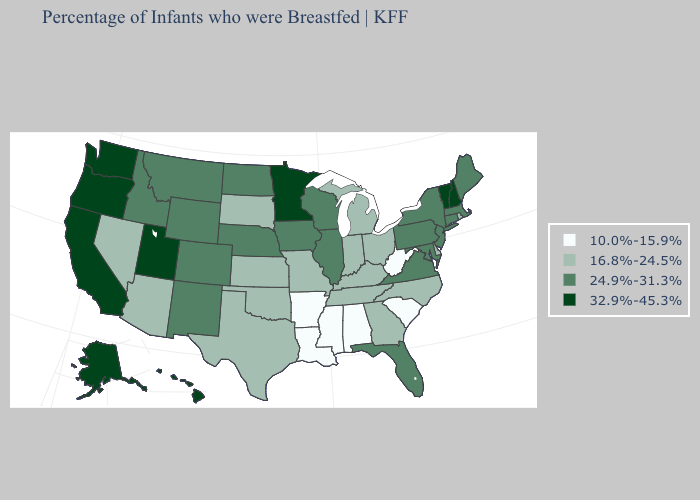Does the first symbol in the legend represent the smallest category?
Give a very brief answer. Yes. Name the states that have a value in the range 32.9%-45.3%?
Quick response, please. Alaska, California, Hawaii, Minnesota, New Hampshire, Oregon, Utah, Vermont, Washington. What is the lowest value in the West?
Answer briefly. 16.8%-24.5%. Does Virginia have a lower value than Rhode Island?
Keep it brief. No. Which states have the lowest value in the MidWest?
Short answer required. Indiana, Kansas, Michigan, Missouri, Ohio, South Dakota. What is the highest value in the USA?
Keep it brief. 32.9%-45.3%. Does the map have missing data?
Quick response, please. No. Which states have the highest value in the USA?
Write a very short answer. Alaska, California, Hawaii, Minnesota, New Hampshire, Oregon, Utah, Vermont, Washington. Which states have the lowest value in the USA?
Give a very brief answer. Alabama, Arkansas, Louisiana, Mississippi, South Carolina, West Virginia. What is the value of Alabama?
Give a very brief answer. 10.0%-15.9%. Does the map have missing data?
Answer briefly. No. What is the lowest value in states that border Georgia?
Write a very short answer. 10.0%-15.9%. Name the states that have a value in the range 24.9%-31.3%?
Quick response, please. Colorado, Connecticut, Florida, Idaho, Illinois, Iowa, Maine, Maryland, Massachusetts, Montana, Nebraska, New Jersey, New Mexico, New York, North Dakota, Pennsylvania, Virginia, Wisconsin, Wyoming. Which states hav the highest value in the West?
Give a very brief answer. Alaska, California, Hawaii, Oregon, Utah, Washington. Name the states that have a value in the range 16.8%-24.5%?
Keep it brief. Arizona, Delaware, Georgia, Indiana, Kansas, Kentucky, Michigan, Missouri, Nevada, North Carolina, Ohio, Oklahoma, Rhode Island, South Dakota, Tennessee, Texas. 